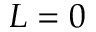<formula> <loc_0><loc_0><loc_500><loc_500>L = 0</formula> 